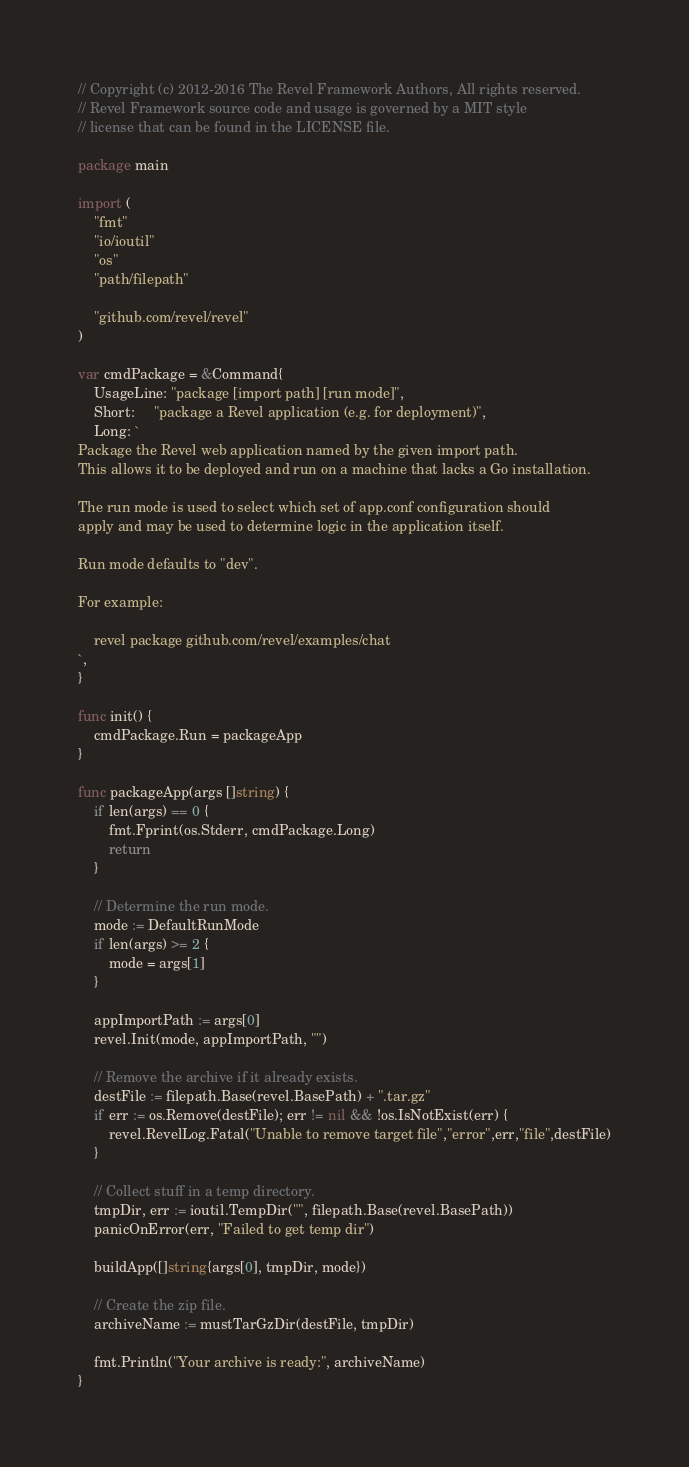Convert code to text. <code><loc_0><loc_0><loc_500><loc_500><_Go_>// Copyright (c) 2012-2016 The Revel Framework Authors, All rights reserved.
// Revel Framework source code and usage is governed by a MIT style
// license that can be found in the LICENSE file.

package main

import (
	"fmt"
	"io/ioutil"
	"os"
	"path/filepath"

	"github.com/revel/revel"
)

var cmdPackage = &Command{
	UsageLine: "package [import path] [run mode]",
	Short:     "package a Revel application (e.g. for deployment)",
	Long: `
Package the Revel web application named by the given import path.
This allows it to be deployed and run on a machine that lacks a Go installation.

The run mode is used to select which set of app.conf configuration should
apply and may be used to determine logic in the application itself.

Run mode defaults to "dev".

For example:

    revel package github.com/revel/examples/chat
`,
}

func init() {
	cmdPackage.Run = packageApp
}

func packageApp(args []string) {
	if len(args) == 0 {
		fmt.Fprint(os.Stderr, cmdPackage.Long)
		return
	}

	// Determine the run mode.
	mode := DefaultRunMode
	if len(args) >= 2 {
		mode = args[1]
	}

	appImportPath := args[0]
	revel.Init(mode, appImportPath, "")

	// Remove the archive if it already exists.
	destFile := filepath.Base(revel.BasePath) + ".tar.gz"
	if err := os.Remove(destFile); err != nil && !os.IsNotExist(err) {
		revel.RevelLog.Fatal("Unable to remove target file","error",err,"file",destFile)
	}

	// Collect stuff in a temp directory.
	tmpDir, err := ioutil.TempDir("", filepath.Base(revel.BasePath))
	panicOnError(err, "Failed to get temp dir")

	buildApp([]string{args[0], tmpDir, mode})

	// Create the zip file.
	archiveName := mustTarGzDir(destFile, tmpDir)

	fmt.Println("Your archive is ready:", archiveName)
}
</code> 